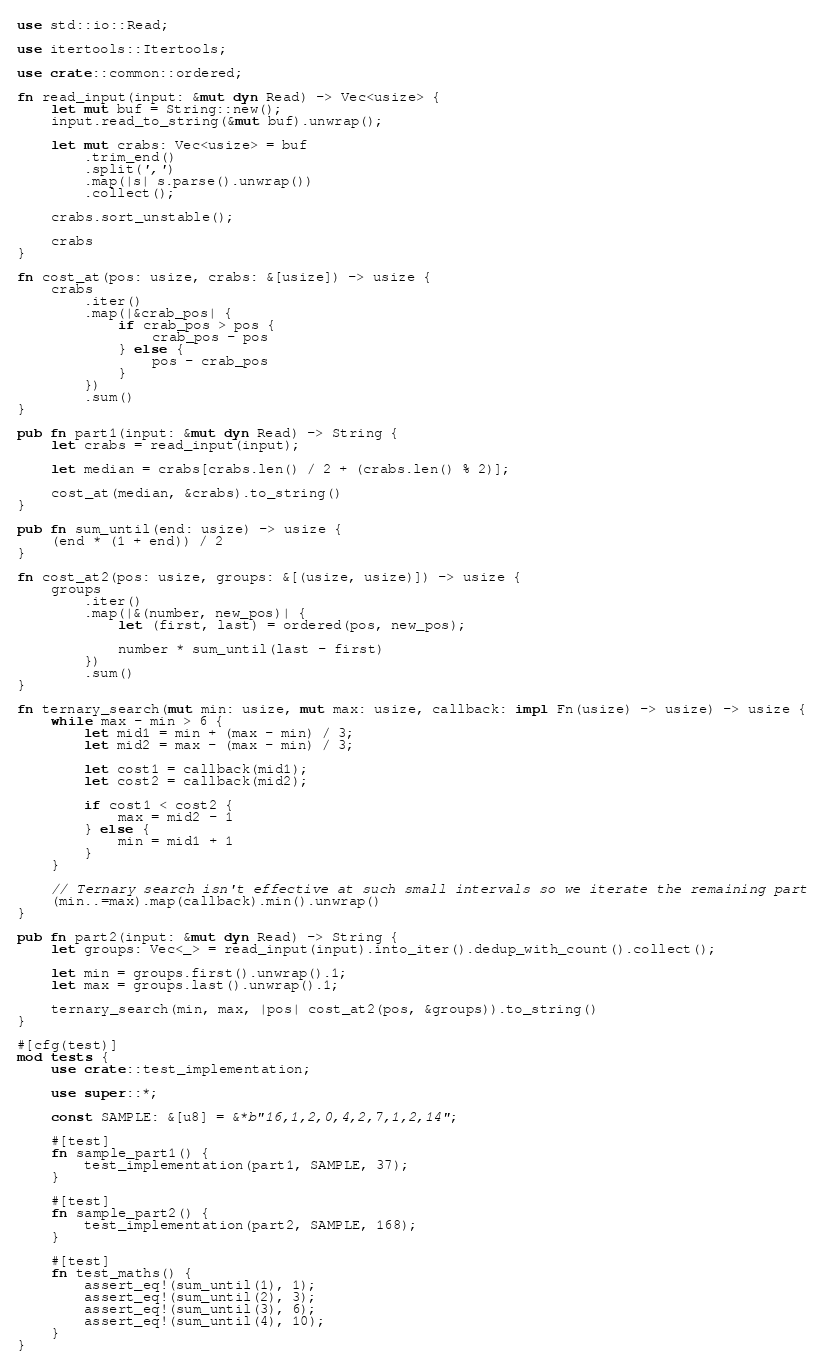Convert code to text. <code><loc_0><loc_0><loc_500><loc_500><_Rust_>use std::io::Read;

use itertools::Itertools;

use crate::common::ordered;

fn read_input(input: &mut dyn Read) -> Vec<usize> {
    let mut buf = String::new();
    input.read_to_string(&mut buf).unwrap();

    let mut crabs: Vec<usize> = buf
        .trim_end()
        .split(',')
        .map(|s| s.parse().unwrap())
        .collect();

    crabs.sort_unstable();

    crabs
}

fn cost_at(pos: usize, crabs: &[usize]) -> usize {
    crabs
        .iter()
        .map(|&crab_pos| {
            if crab_pos > pos {
                crab_pos - pos
            } else {
                pos - crab_pos
            }
        })
        .sum()
}

pub fn part1(input: &mut dyn Read) -> String {
    let crabs = read_input(input);

    let median = crabs[crabs.len() / 2 + (crabs.len() % 2)];

    cost_at(median, &crabs).to_string()
}

pub fn sum_until(end: usize) -> usize {
    (end * (1 + end)) / 2
}

fn cost_at2(pos: usize, groups: &[(usize, usize)]) -> usize {
    groups
        .iter()
        .map(|&(number, new_pos)| {
            let (first, last) = ordered(pos, new_pos);

            number * sum_until(last - first)
        })
        .sum()
}

fn ternary_search(mut min: usize, mut max: usize, callback: impl Fn(usize) -> usize) -> usize {
    while max - min > 6 {
        let mid1 = min + (max - min) / 3;
        let mid2 = max - (max - min) / 3;

        let cost1 = callback(mid1);
        let cost2 = callback(mid2);

        if cost1 < cost2 {
            max = mid2 - 1
        } else {
            min = mid1 + 1
        }
    }

    // Ternary search isn't effective at such small intervals so we iterate the remaining part
    (min..=max).map(callback).min().unwrap()
}

pub fn part2(input: &mut dyn Read) -> String {
    let groups: Vec<_> = read_input(input).into_iter().dedup_with_count().collect();

    let min = groups.first().unwrap().1;
    let max = groups.last().unwrap().1;

    ternary_search(min, max, |pos| cost_at2(pos, &groups)).to_string()
}

#[cfg(test)]
mod tests {
    use crate::test_implementation;

    use super::*;

    const SAMPLE: &[u8] = &*b"16,1,2,0,4,2,7,1,2,14";

    #[test]
    fn sample_part1() {
        test_implementation(part1, SAMPLE, 37);
    }

    #[test]
    fn sample_part2() {
        test_implementation(part2, SAMPLE, 168);
    }

    #[test]
    fn test_maths() {
        assert_eq!(sum_until(1), 1);
        assert_eq!(sum_until(2), 3);
        assert_eq!(sum_until(3), 6);
        assert_eq!(sum_until(4), 10);
    }
}
</code> 